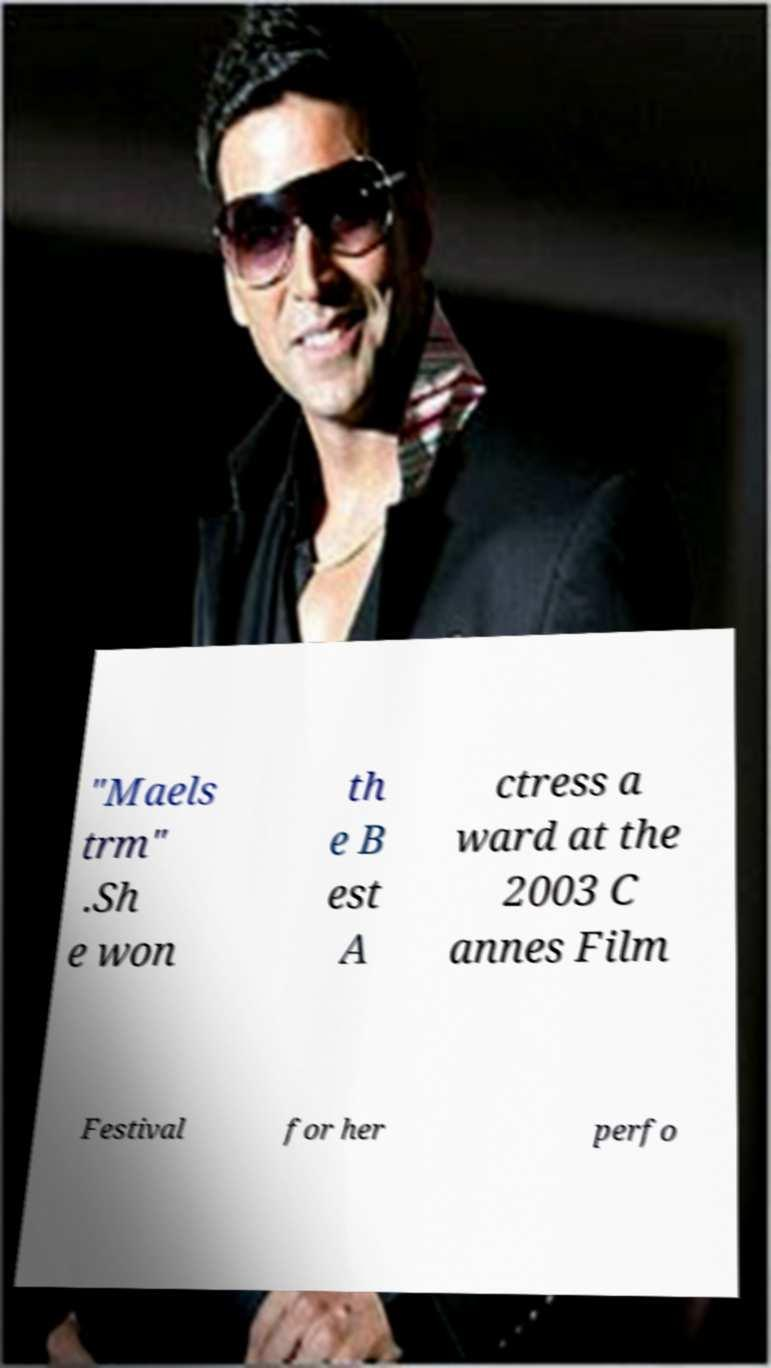I need the written content from this picture converted into text. Can you do that? "Maels trm" .Sh e won th e B est A ctress a ward at the 2003 C annes Film Festival for her perfo 